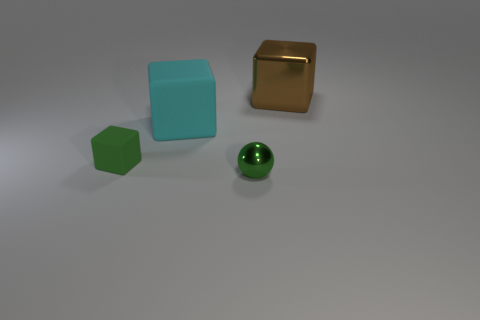Add 1 yellow rubber cylinders. How many objects exist? 5 Subtract all blocks. How many objects are left? 1 Subtract 0 blue spheres. How many objects are left? 4 Subtract all green balls. Subtract all big brown metallic blocks. How many objects are left? 2 Add 2 balls. How many balls are left? 3 Add 3 big purple metallic blocks. How many big purple metallic blocks exist? 3 